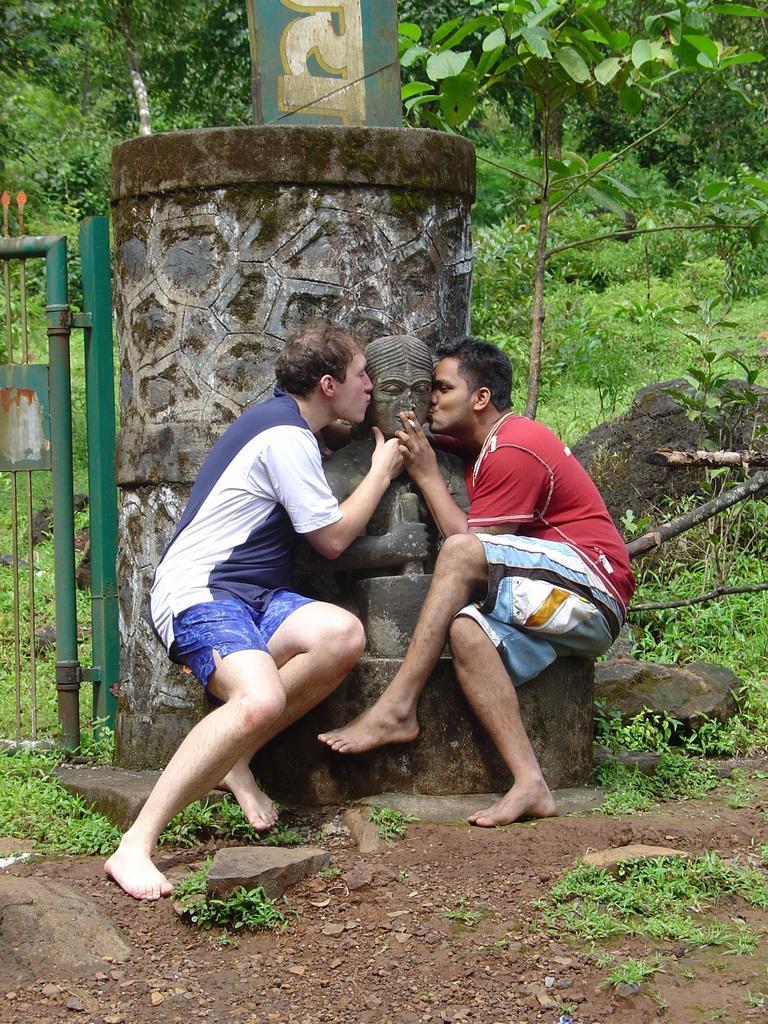In one or two sentences, can you explain what this image depicts? In this image I can see a sculpture and I can see two men are sitting. I can also see both of them are wearing t shirts, shorts and in the background I can see green colour gate, a board, grass and number of trees. 